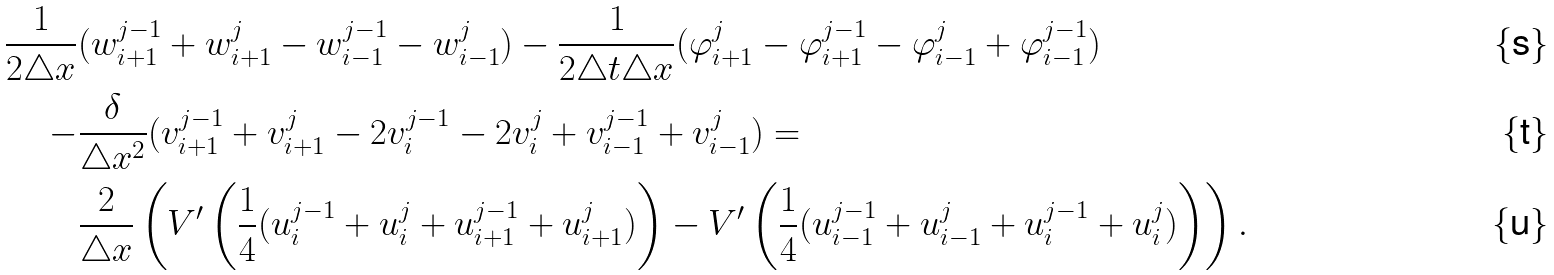<formula> <loc_0><loc_0><loc_500><loc_500>\frac { 1 } { 2 \triangle x } & ( w _ { i + 1 } ^ { j - 1 } + w _ { i + 1 } ^ { j } - w _ { i - 1 } ^ { j - 1 } - w _ { i - 1 } ^ { j } ) - \frac { 1 } { 2 \triangle t \triangle x } ( \varphi _ { i + 1 } ^ { j } - \varphi _ { i + 1 } ^ { j - 1 } - \varphi _ { i - 1 } ^ { j } + \varphi _ { i - 1 } ^ { j - 1 } ) \\ - & \frac { \delta } { \triangle x ^ { 2 } } ( v _ { i + 1 } ^ { j - 1 } + v _ { i + 1 } ^ { j } - 2 v _ { i } ^ { j - 1 } - 2 v _ { i } ^ { j } + v _ { i - 1 } ^ { j - 1 } + v _ { i - 1 } ^ { j } ) = \\ & \frac { 2 } { \triangle x } \left ( V ^ { \prime } \left ( \frac { 1 } { 4 } ( u _ { i } ^ { j - 1 } + u _ { i } ^ { j } + u _ { i + 1 } ^ { j - 1 } + u _ { i + 1 } ^ { j } ) \right ) - V ^ { \prime } \left ( \frac { 1 } { 4 } ( u _ { i - 1 } ^ { j - 1 } + u _ { i - 1 } ^ { j } + u _ { i } ^ { j - 1 } + u _ { i } ^ { j } ) \right ) \right ) .</formula> 